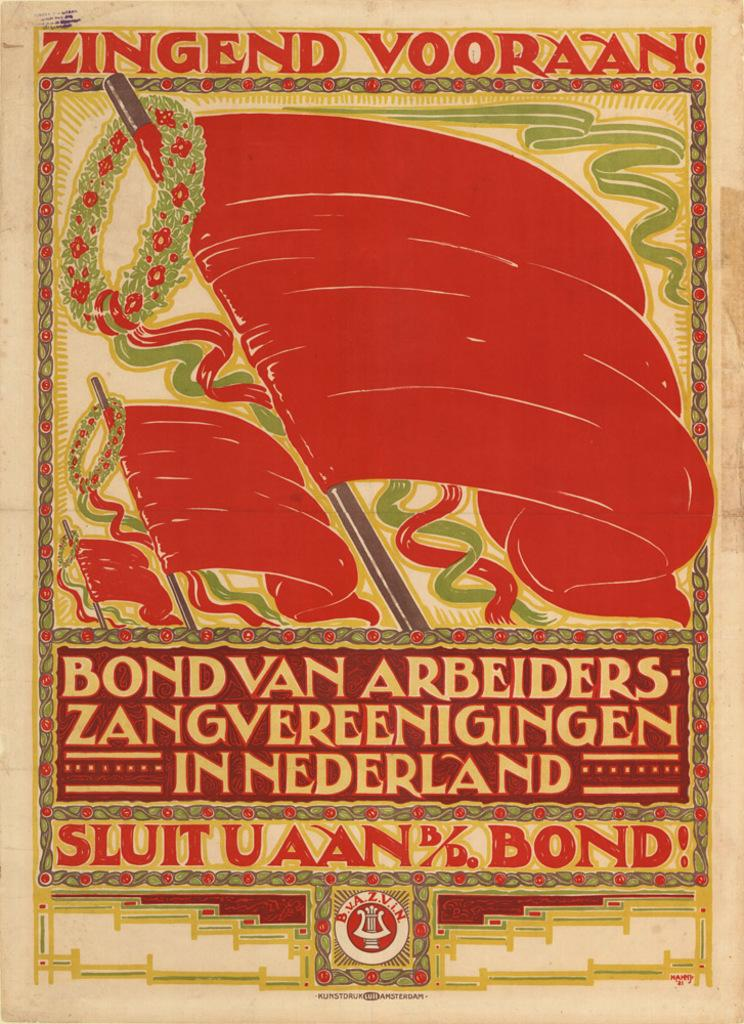<image>
Offer a succinct explanation of the picture presented. A poster with red flags on it that says Zingend Vooraan on the top of it 